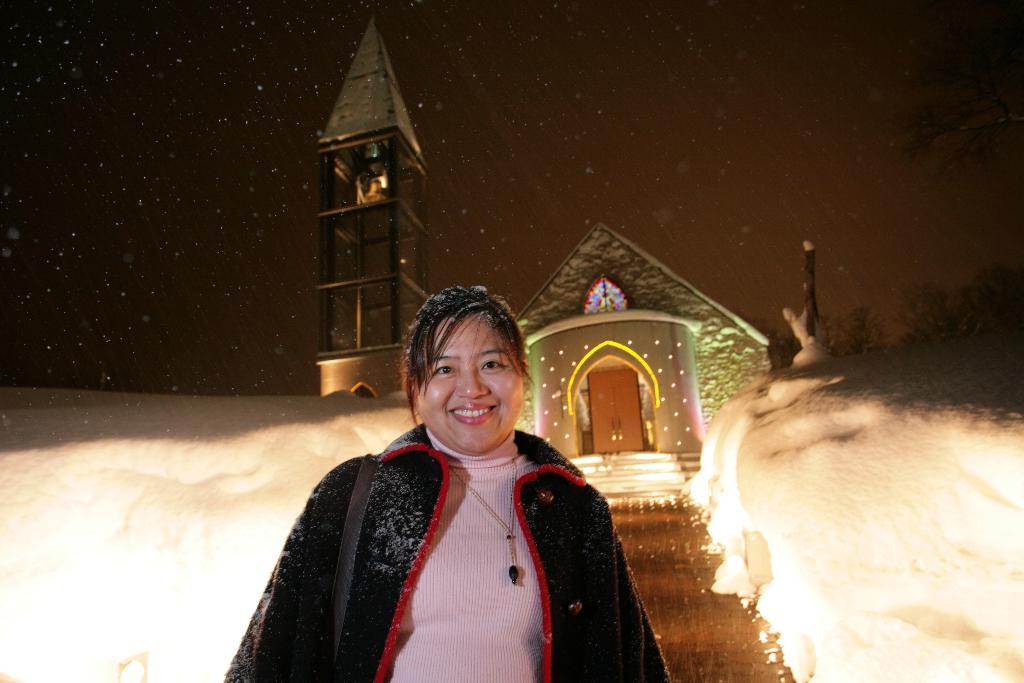Who is present in the image? There is a woman in the image. What is the woman doing in the image? The woman is standing in the image. What is the woman's facial expression in the image? The woman is smiling in the image. What type of weather is depicted in the image? There is snow visible in the image, indicating cold weather. What structure is visible behind the woman? There is a house behind the woman in the image. What is present at the top of the image? Stars and the sky are visible at the top of the image. What type of plantation can be seen in the image? There is no plantation present in the image. How much wealth does the woman possess, as depicted in the image? The image does not provide any information about the woman's wealth. 